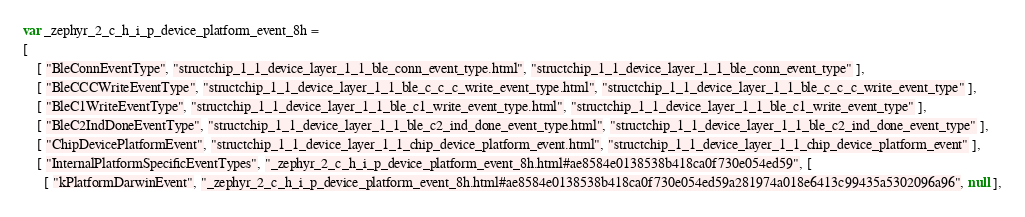<code> <loc_0><loc_0><loc_500><loc_500><_JavaScript_>var _zephyr_2_c_h_i_p_device_platform_event_8h =
[
    [ "BleConnEventType", "structchip_1_1_device_layer_1_1_ble_conn_event_type.html", "structchip_1_1_device_layer_1_1_ble_conn_event_type" ],
    [ "BleCCCWriteEventType", "structchip_1_1_device_layer_1_1_ble_c_c_c_write_event_type.html", "structchip_1_1_device_layer_1_1_ble_c_c_c_write_event_type" ],
    [ "BleC1WriteEventType", "structchip_1_1_device_layer_1_1_ble_c1_write_event_type.html", "structchip_1_1_device_layer_1_1_ble_c1_write_event_type" ],
    [ "BleC2IndDoneEventType", "structchip_1_1_device_layer_1_1_ble_c2_ind_done_event_type.html", "structchip_1_1_device_layer_1_1_ble_c2_ind_done_event_type" ],
    [ "ChipDevicePlatformEvent", "structchip_1_1_device_layer_1_1_chip_device_platform_event.html", "structchip_1_1_device_layer_1_1_chip_device_platform_event" ],
    [ "InternalPlatformSpecificEventTypes", "_zephyr_2_c_h_i_p_device_platform_event_8h.html#ae8584e0138538b418ca0f730e054ed59", [
      [ "kPlatformDarwinEvent", "_zephyr_2_c_h_i_p_device_platform_event_8h.html#ae8584e0138538b418ca0f730e054ed59a281974a018e6413c99435a5302096a96", null ],</code> 